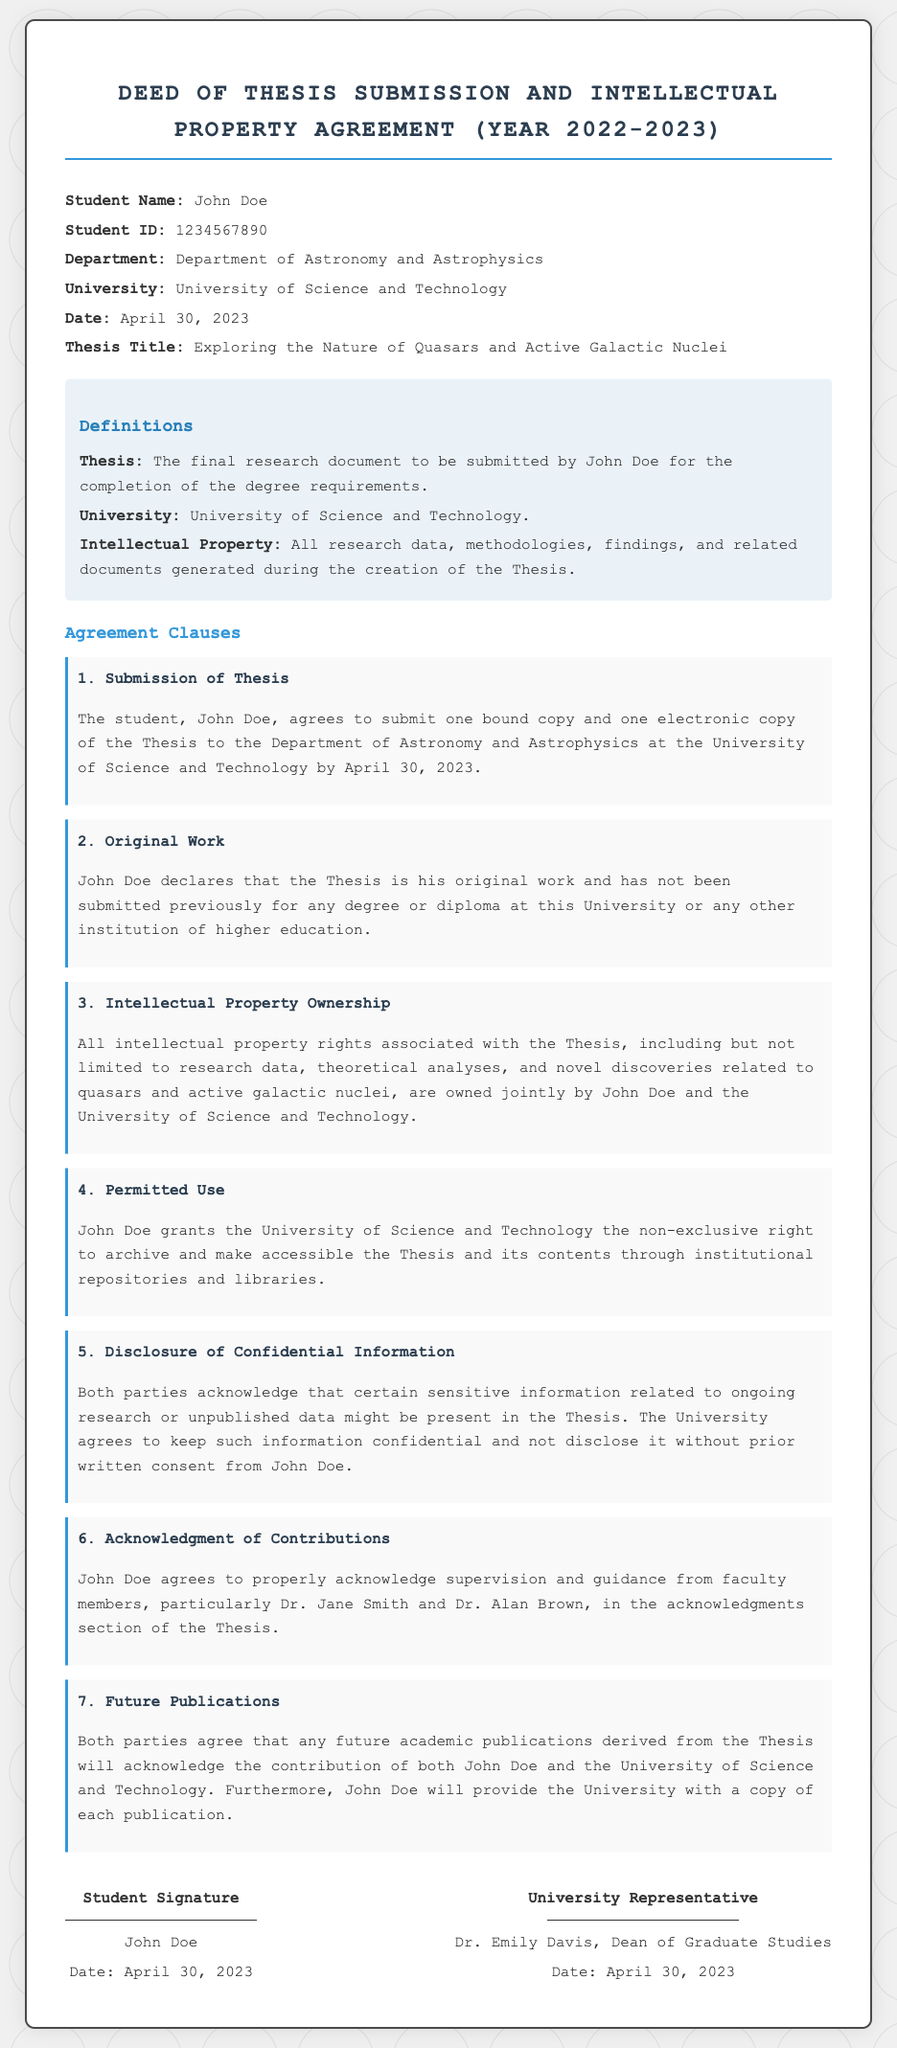What is the student's name? The student's name is stated in the document and is John Doe.
Answer: John Doe What is the thesis title? The thesis title is mentioned in the information section, which is "Exploring the Nature of Quasars and Active Galactic Nuclei."
Answer: Exploring the Nature of Quasars and Active Galactic Nuclei What date is the thesis due? The due date for the thesis submission is clearly specified in the document as April 30, 2023.
Answer: April 30, 2023 Who are the faculty members acknowledged in the thesis? The document lists Dr. Jane Smith and Dr. Alan Brown as the faculty members to be acknowledged.
Answer: Dr. Jane Smith and Dr. Alan Brown What is the ownership status of intellectual property related to the thesis? The ownership status is detailed in the document, stating that it is jointly owned by John Doe and the University of Science and Technology.
Answer: John Doe and the University of Science and Technology What is clause 5 about? Clause 5 discusses the confidentiality of sensitive information included in the thesis and the agreement to keep it confidential.
Answer: Disclosure of Confidential Information How many copies of the thesis must be submitted? The document specifies that one bound copy and one electronic copy must be submitted.
Answer: One bound copy and one electronic copy What is the relationship between future publications and the thesis? The document states that future academic publications derived from the thesis must acknowledge the contributions of both the student and the university.
Answer: Acknowledge the contribution of both John Doe and the University of Science and Technology 